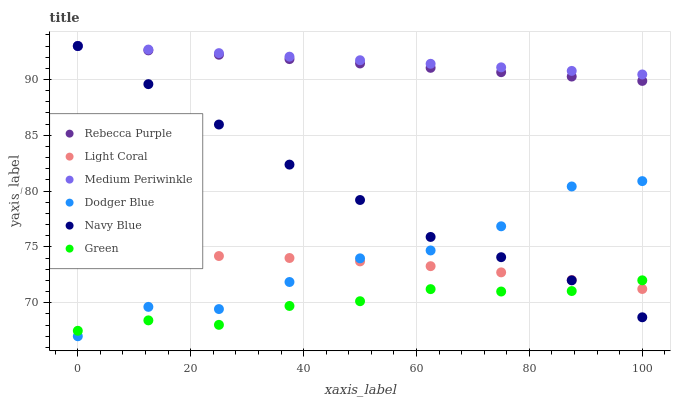Does Green have the minimum area under the curve?
Answer yes or no. Yes. Does Medium Periwinkle have the maximum area under the curve?
Answer yes or no. Yes. Does Light Coral have the minimum area under the curve?
Answer yes or no. No. Does Light Coral have the maximum area under the curve?
Answer yes or no. No. Is Medium Periwinkle the smoothest?
Answer yes or no. Yes. Is Dodger Blue the roughest?
Answer yes or no. Yes. Is Light Coral the smoothest?
Answer yes or no. No. Is Light Coral the roughest?
Answer yes or no. No. Does Dodger Blue have the lowest value?
Answer yes or no. Yes. Does Light Coral have the lowest value?
Answer yes or no. No. Does Rebecca Purple have the highest value?
Answer yes or no. Yes. Does Light Coral have the highest value?
Answer yes or no. No. Is Green less than Rebecca Purple?
Answer yes or no. Yes. Is Rebecca Purple greater than Dodger Blue?
Answer yes or no. Yes. Does Rebecca Purple intersect Navy Blue?
Answer yes or no. Yes. Is Rebecca Purple less than Navy Blue?
Answer yes or no. No. Is Rebecca Purple greater than Navy Blue?
Answer yes or no. No. Does Green intersect Rebecca Purple?
Answer yes or no. No. 